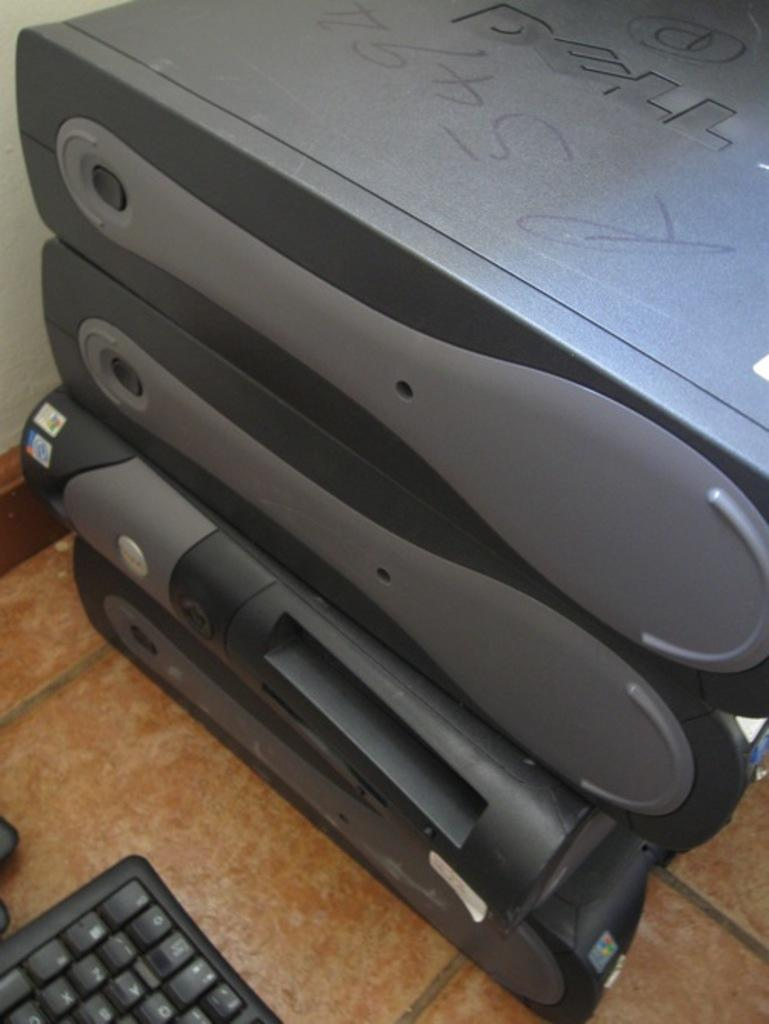What type of electronic device is visible in the image? There is a CPU in the image. What other peripheral device can be seen in the image? There is a keyboard on the floor in the image. What type of copper material is used to make the ground in the image? There is no mention of copper or ground in the image; it features a CPU and a keyboard. How many apples are visible on the keyboard in the image? There are no apples present on the keyboard in the image. 